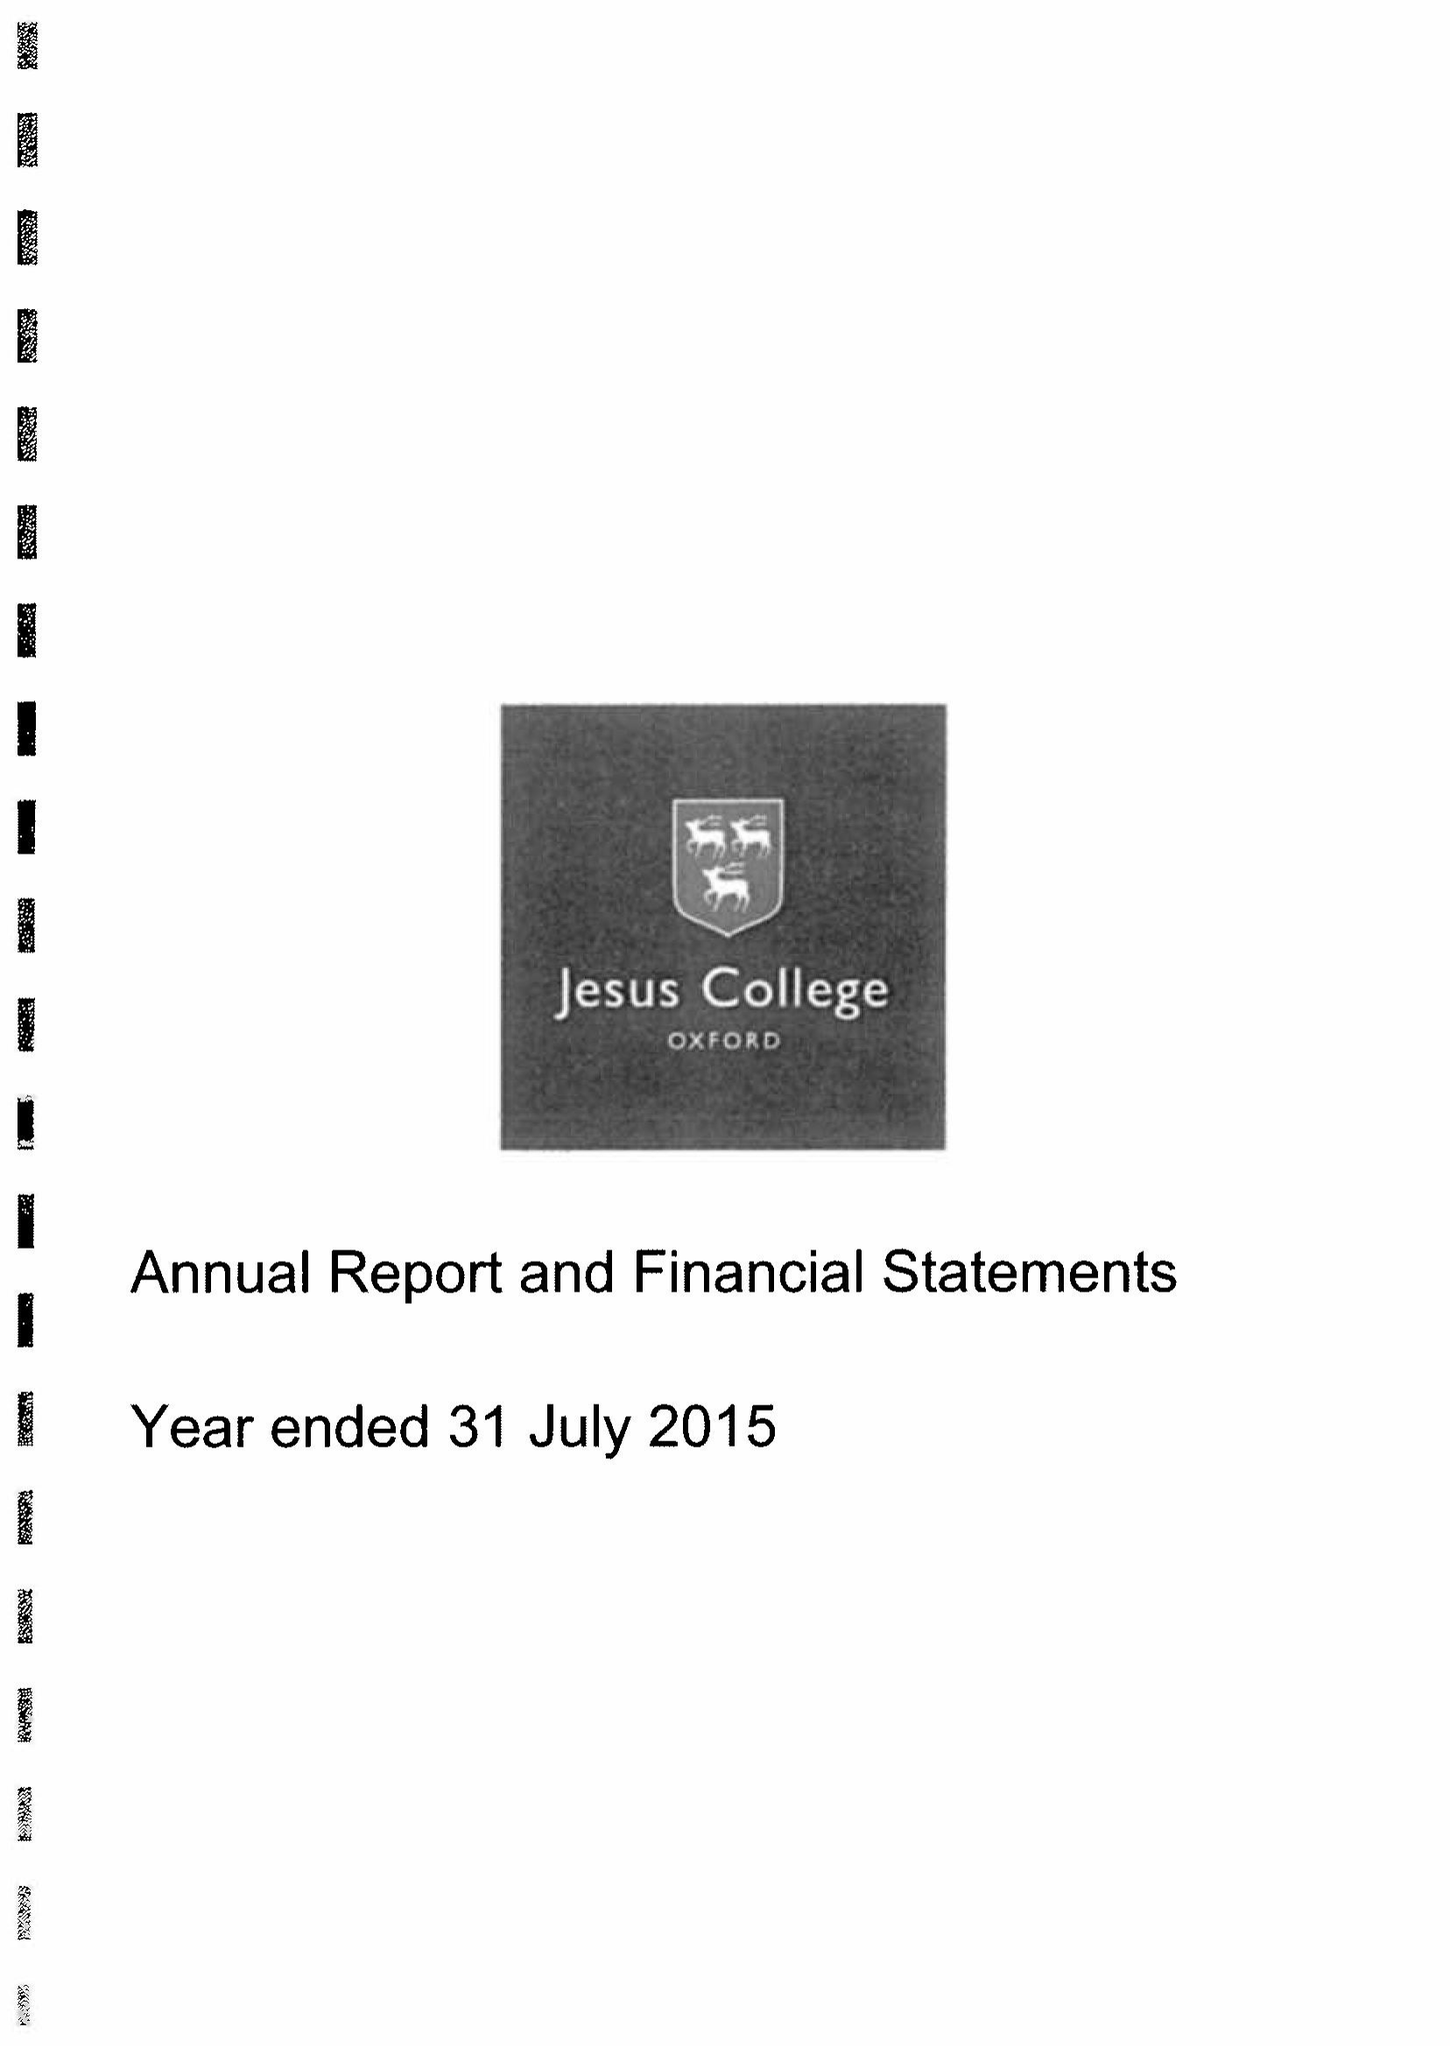What is the value for the spending_annually_in_british_pounds?
Answer the question using a single word or phrase. 11892000.00 